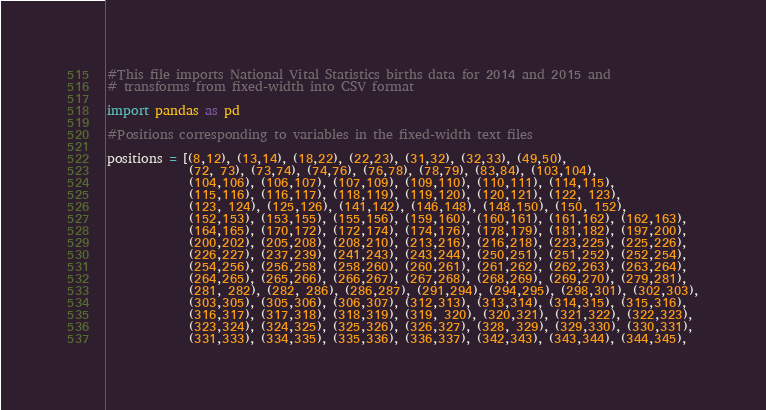<code> <loc_0><loc_0><loc_500><loc_500><_Python_>#This file imports National Vital Statistics births data for 2014 and 2015 and
# transforms from fixed-width into CSV format

import pandas as pd

#Positions corresponding to variables in the fixed-width text files

positions = [(8,12), (13,14), (18,22), (22,23), (31,32), (32,33), (49,50),
             (72, 73), (73,74), (74,76), (76,78), (78,79), (83,84), (103,104),
             (104,106), (106,107), (107,109), (109,110), (110,111), (114,115),
             (115,116), (116,117), (118,119), (119,120), (120,121), (122, 123),
             (123, 124), (125,126), (141,142), (146,148), (148,150), (150, 152),
             (152,153), (153,155), (155,156), (159,160), (160,161), (161,162), (162,163),
             (164,165), (170,172), (172,174), (174,176), (178,179), (181,182), (197,200),
             (200,202), (205,208), (208,210), (213,216), (216,218), (223,225), (225,226),
             (226,227), (237,239), (241,243), (243,244), (250,251), (251,252), (252,254),
             (254,256), (256,258), (258,260), (260,261), (261,262), (262,263), (263,264),
             (264,265), (265,266), (266,267), (267,268), (268,269), (269,270), (279,281),
             (281, 282), (282, 286), (286,287), (291,294), (294,295), (298,301), (302,303),
             (303,305), (305,306), (306,307), (312,313), (313,314), (314,315), (315,316),
             (316,317), (317,318), (318,319), (319, 320), (320,321), (321,322), (322,323),
             (323,324), (324,325), (325,326), (326,327), (328, 329), (329,330), (330,331),
             (331,333), (334,335), (335,336), (336,337), (342,343), (343,344), (344,345),</code> 